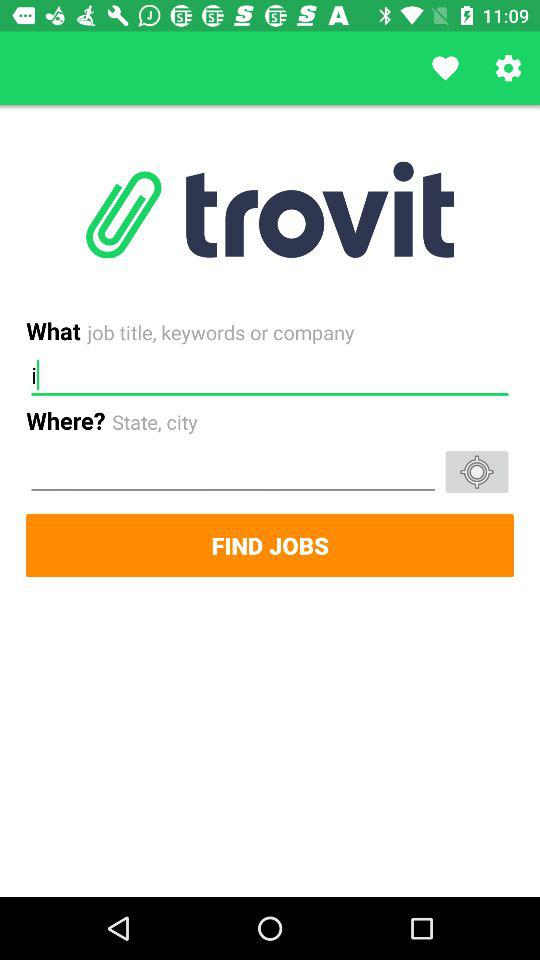How many days are left? There are 2 days left. 